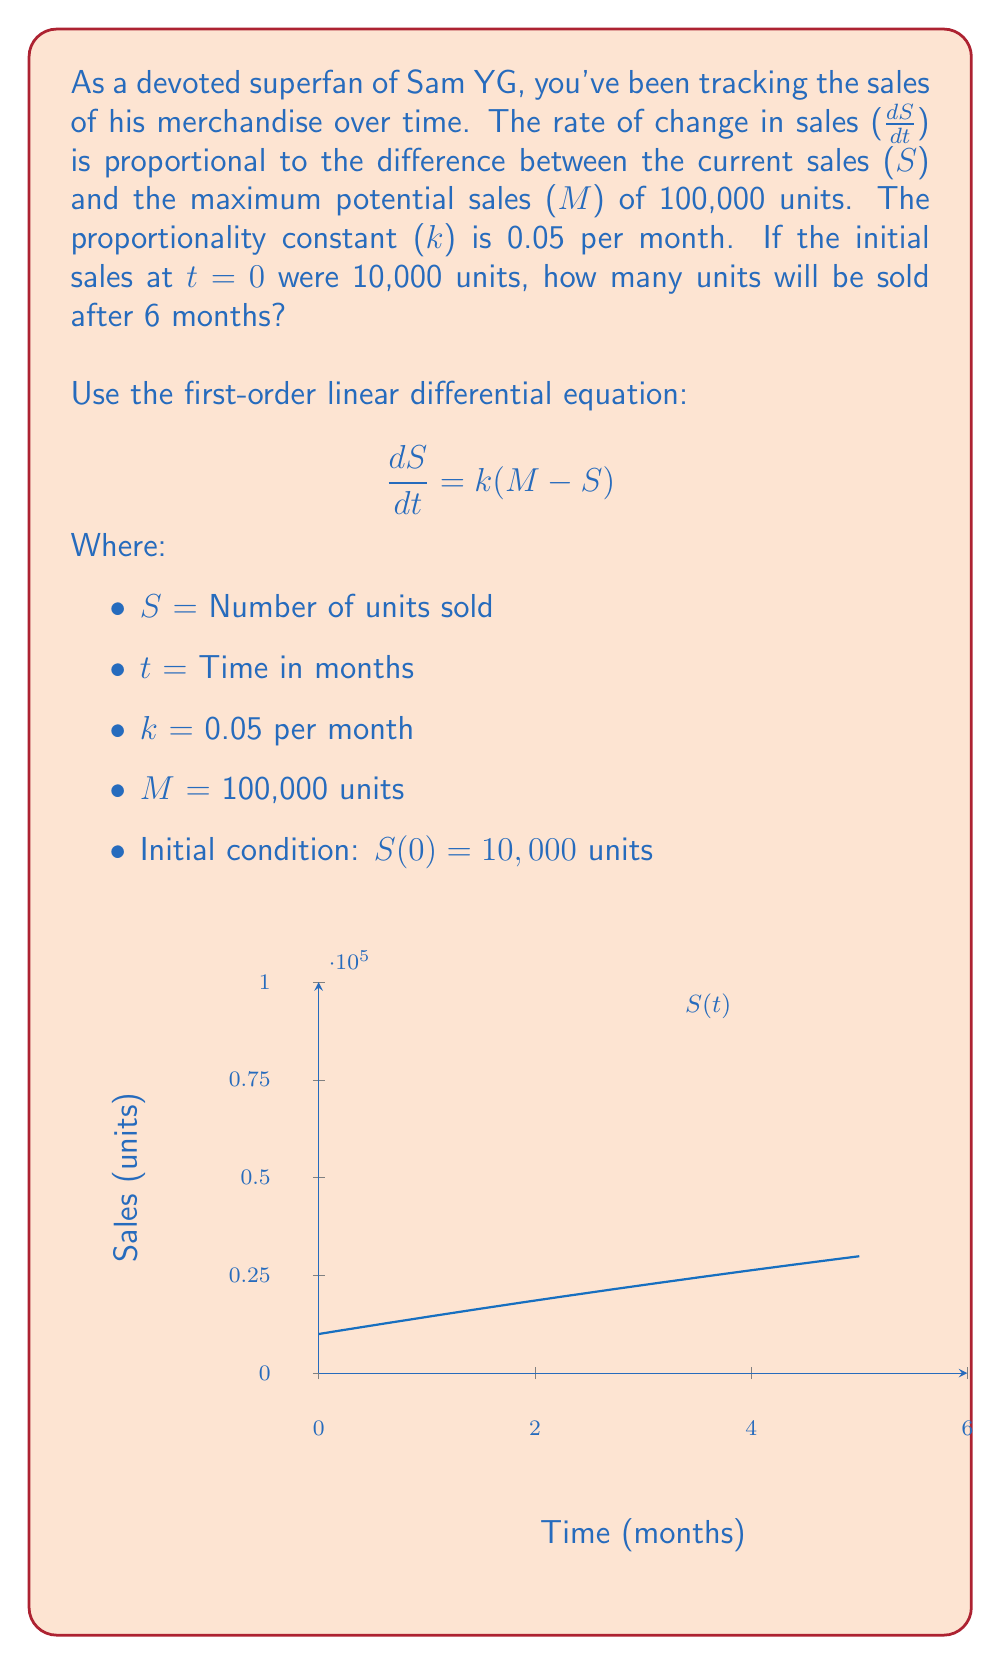Provide a solution to this math problem. To solve this first-order linear differential equation:

1) Rearrange the equation:
   $$\frac{dS}{dt} = 0.05(100000 - S)$$

2) Separate variables:
   $$\frac{dS}{100000 - S} = 0.05dt$$

3) Integrate both sides:
   $$-\ln|100000 - S| = 0.05t + C$$

4) Solve for S:
   $$100000 - S = e^{-(0.05t + C)}$$
   $$S = 100000 - Ae^{-0.05t}$$, where $A = e^C$

5) Use the initial condition S(0) = 10000 to find A:
   $$10000 = 100000 - A$$
   $$A = 90000$$

6) The solution is:
   $$S(t) = 100000 - 90000e^{-0.05t}$$

7) Calculate S(6):
   $$S(6) = 100000 - 90000e^{-0.05(6)}$$
   $$S(6) = 100000 - 90000(0.7408)$$
   $$S(6) = 100000 - 66672$$
   $$S(6) = 33328$$

Therefore, after 6 months, approximately 33,328 units will be sold.
Answer: 33,328 units 